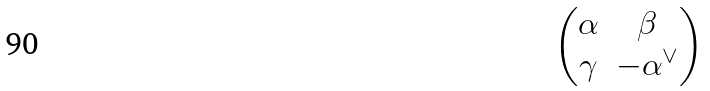Convert formula to latex. <formula><loc_0><loc_0><loc_500><loc_500>\begin{pmatrix} \alpha & \beta \\ \gamma & - \alpha ^ { \vee } \end{pmatrix}</formula> 